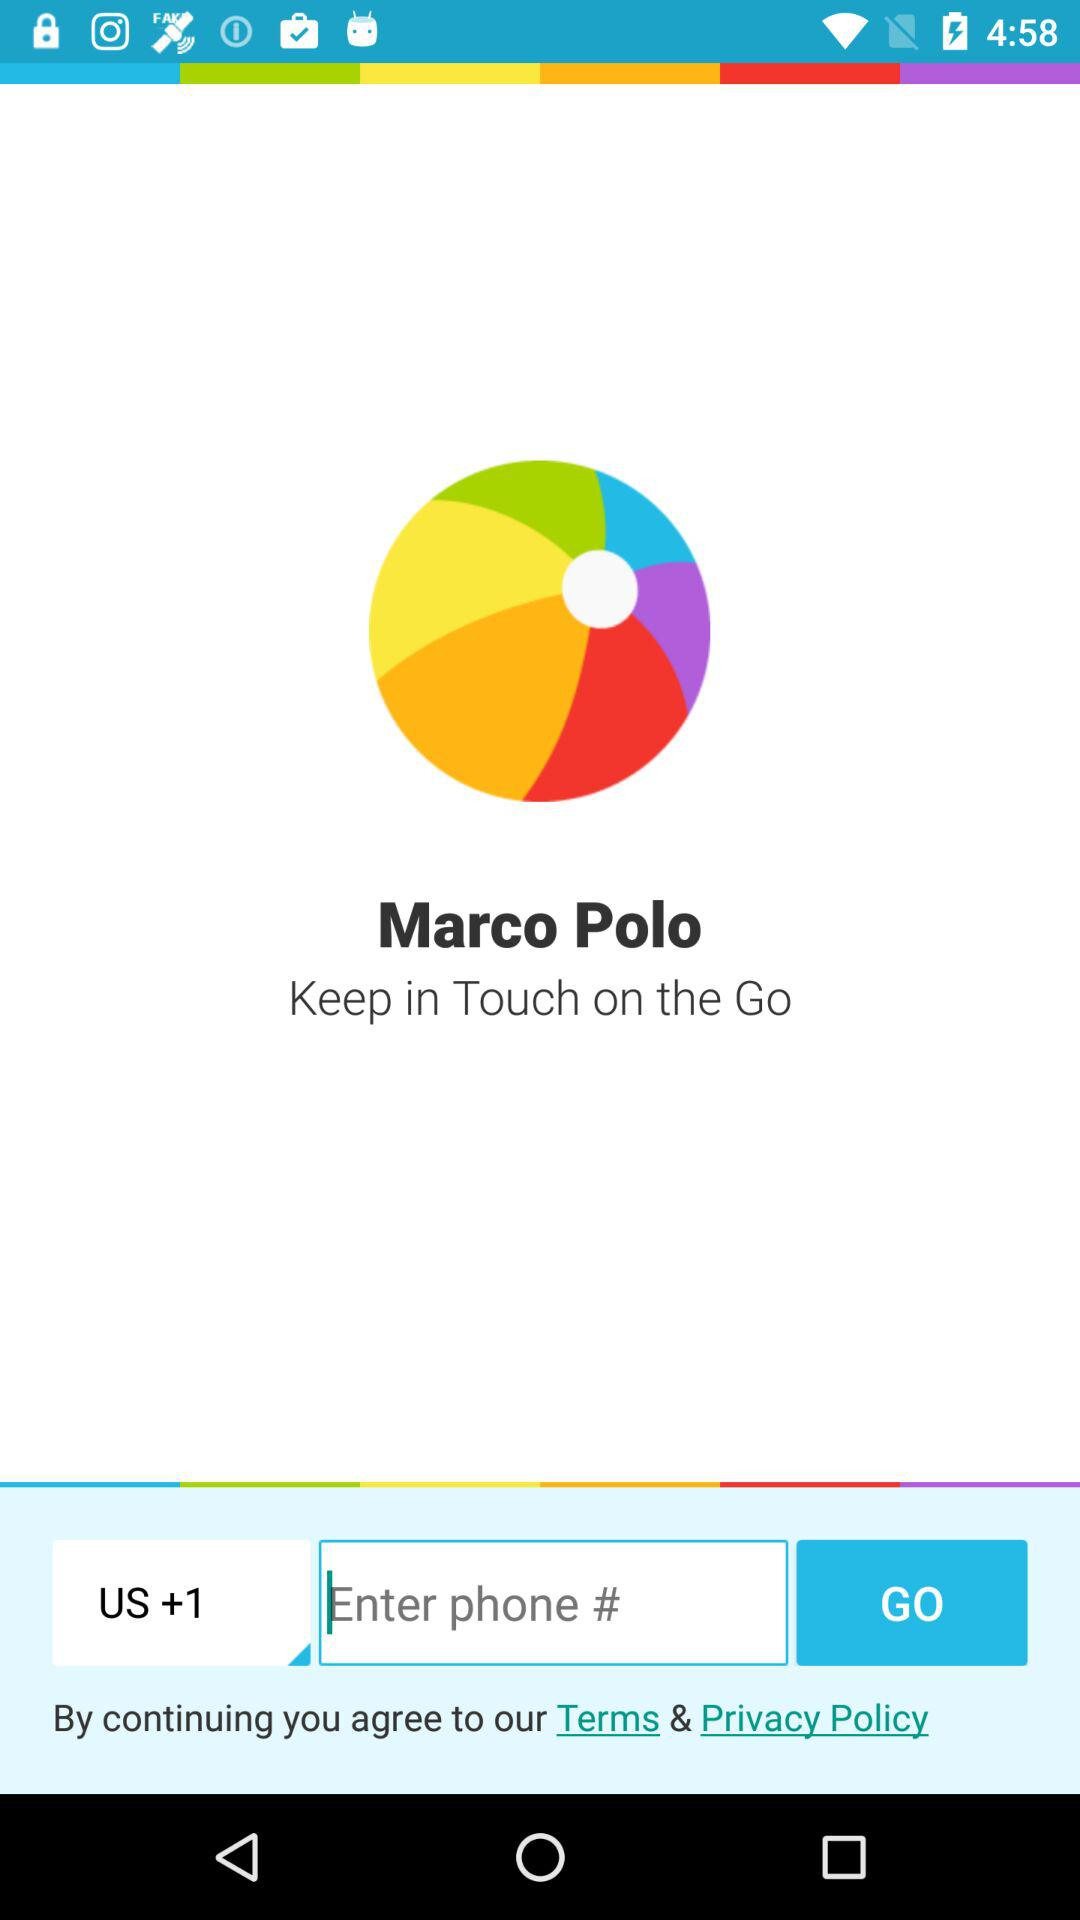What is the application name? The application name is "Marco Polo". 